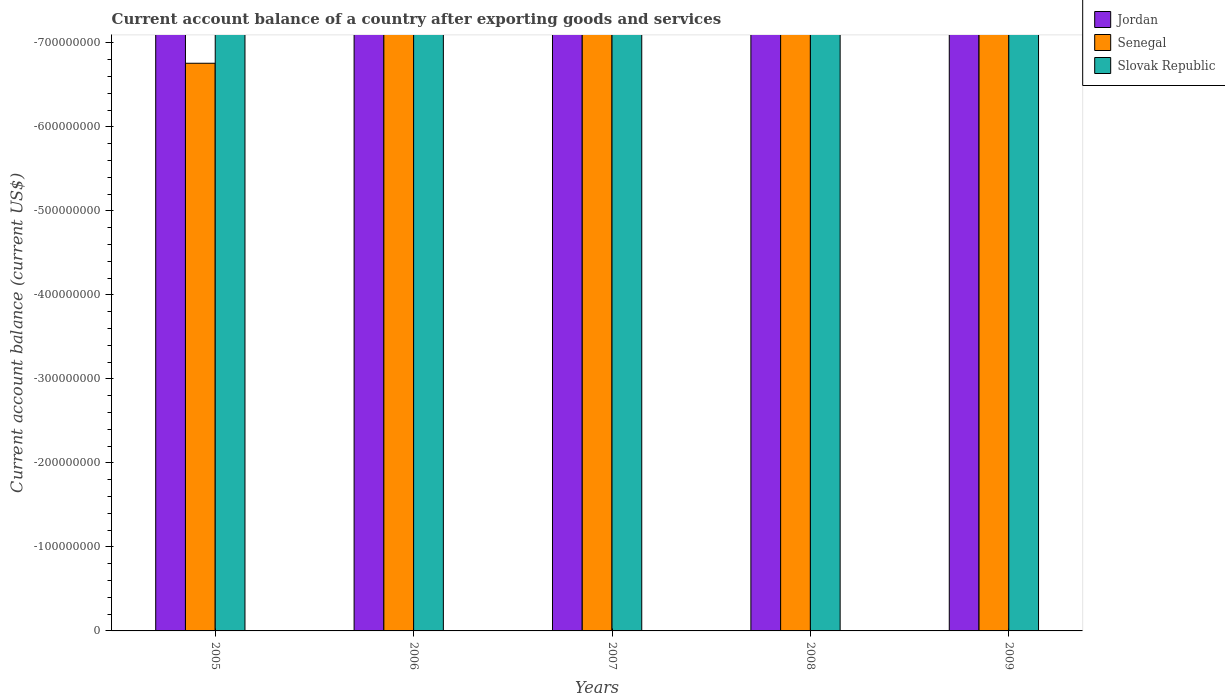How many different coloured bars are there?
Keep it short and to the point. 0. Are the number of bars per tick equal to the number of legend labels?
Your answer should be very brief. No. Are the number of bars on each tick of the X-axis equal?
Offer a terse response. Yes. How many bars are there on the 2nd tick from the left?
Offer a terse response. 0. How many bars are there on the 2nd tick from the right?
Provide a short and direct response. 0. What is the label of the 3rd group of bars from the left?
Ensure brevity in your answer.  2007. What is the total account balance in Senegal in the graph?
Make the answer very short. 0. What is the difference between the account balance in Jordan in 2008 and the account balance in Senegal in 2006?
Provide a succinct answer. 0. What is the average account balance in Senegal per year?
Ensure brevity in your answer.  0. In how many years, is the account balance in Senegal greater than -680000000 US$?
Keep it short and to the point. 1. How many years are there in the graph?
Offer a very short reply. 5. Are the values on the major ticks of Y-axis written in scientific E-notation?
Provide a short and direct response. No. Does the graph contain grids?
Your answer should be compact. No. What is the title of the graph?
Provide a short and direct response. Current account balance of a country after exporting goods and services. Does "High income: OECD" appear as one of the legend labels in the graph?
Keep it short and to the point. No. What is the label or title of the Y-axis?
Offer a terse response. Current account balance (current US$). What is the Current account balance (current US$) in Jordan in 2006?
Offer a very short reply. 0. What is the Current account balance (current US$) in Slovak Republic in 2006?
Provide a short and direct response. 0. What is the Current account balance (current US$) in Senegal in 2007?
Provide a succinct answer. 0. What is the Current account balance (current US$) of Senegal in 2008?
Make the answer very short. 0. What is the Current account balance (current US$) of Senegal in 2009?
Your answer should be compact. 0. What is the total Current account balance (current US$) in Jordan in the graph?
Offer a very short reply. 0. What is the average Current account balance (current US$) in Senegal per year?
Your answer should be very brief. 0. 